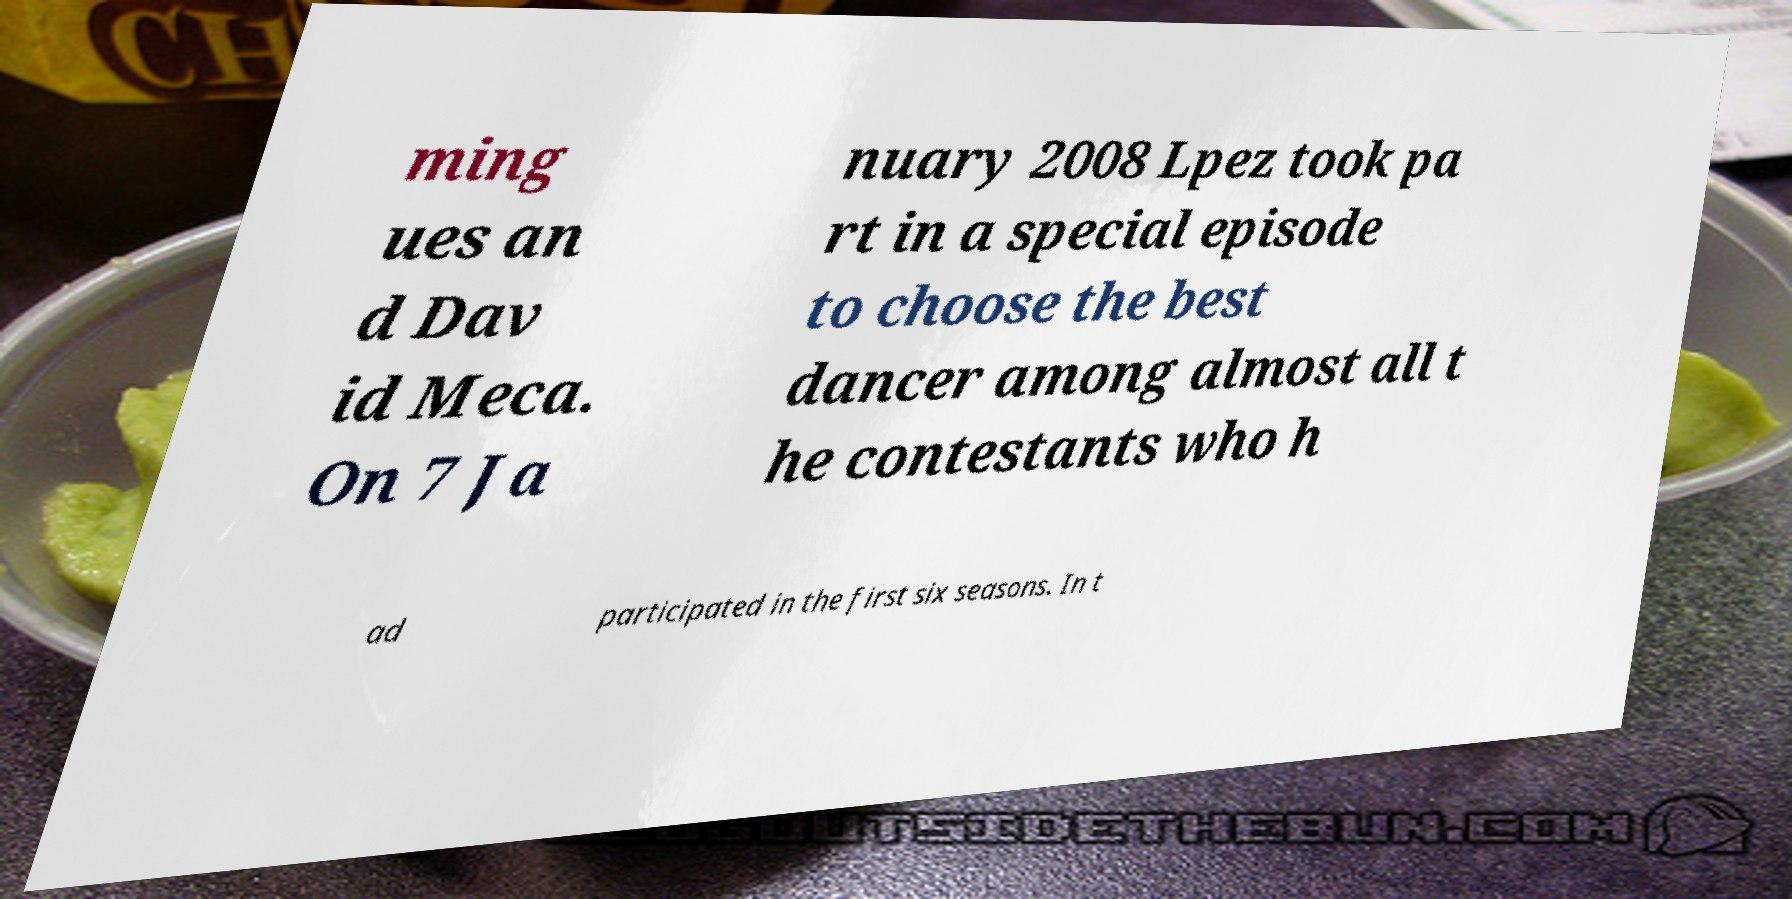Can you accurately transcribe the text from the provided image for me? ming ues an d Dav id Meca. On 7 Ja nuary 2008 Lpez took pa rt in a special episode to choose the best dancer among almost all t he contestants who h ad participated in the first six seasons. In t 